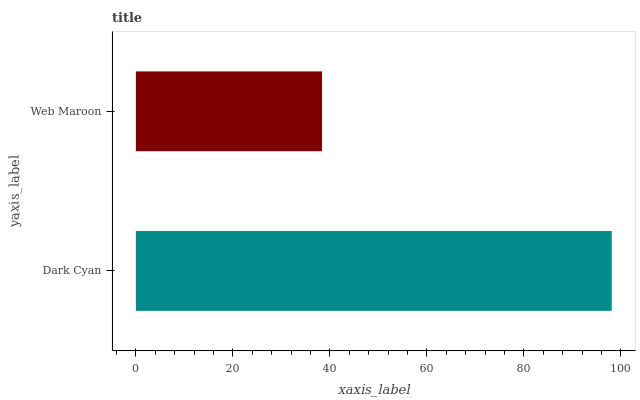Is Web Maroon the minimum?
Answer yes or no. Yes. Is Dark Cyan the maximum?
Answer yes or no. Yes. Is Web Maroon the maximum?
Answer yes or no. No. Is Dark Cyan greater than Web Maroon?
Answer yes or no. Yes. Is Web Maroon less than Dark Cyan?
Answer yes or no. Yes. Is Web Maroon greater than Dark Cyan?
Answer yes or no. No. Is Dark Cyan less than Web Maroon?
Answer yes or no. No. Is Dark Cyan the high median?
Answer yes or no. Yes. Is Web Maroon the low median?
Answer yes or no. Yes. Is Web Maroon the high median?
Answer yes or no. No. Is Dark Cyan the low median?
Answer yes or no. No. 